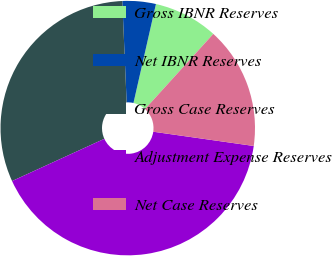Convert chart. <chart><loc_0><loc_0><loc_500><loc_500><pie_chart><fcel>Gross IBNR Reserves<fcel>Net IBNR Reserves<fcel>Gross Case Reserves<fcel>Adjustment Expense Reserves<fcel>Net Case Reserves<nl><fcel>8.18%<fcel>4.24%<fcel>31.15%<fcel>40.93%<fcel>15.51%<nl></chart> 